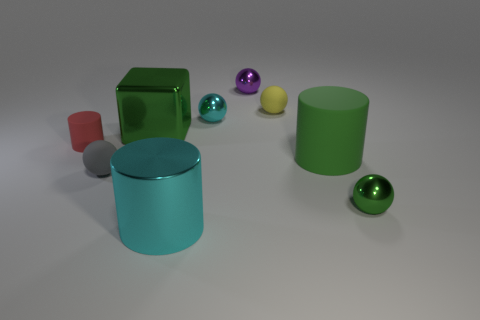There is a cube that is the same color as the large rubber cylinder; what is it made of?
Make the answer very short. Metal. There is a block that is the same color as the big rubber cylinder; what is its size?
Your answer should be very brief. Large. Does the cylinder that is to the right of the small cyan metal thing have the same color as the large metallic block that is in front of the purple object?
Ensure brevity in your answer.  Yes. How many things are either green metallic blocks or green metallic objects?
Provide a succinct answer. 2. How many other things are there of the same shape as the small red thing?
Your response must be concise. 2. Do the cyan object that is in front of the small gray object and the large green thing to the right of the purple shiny sphere have the same material?
Give a very brief answer. No. There is a big object that is on the left side of the purple metallic thing and behind the shiny cylinder; what shape is it?
Ensure brevity in your answer.  Cube. There is a cylinder that is to the right of the gray object and left of the green matte cylinder; what is it made of?
Provide a short and direct response. Metal. There is a large green object that is made of the same material as the tiny purple object; what is its shape?
Provide a succinct answer. Cube. Are there any other things that have the same color as the tiny rubber cylinder?
Your response must be concise. No. 